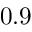<formula> <loc_0><loc_0><loc_500><loc_500>0 . 9</formula> 